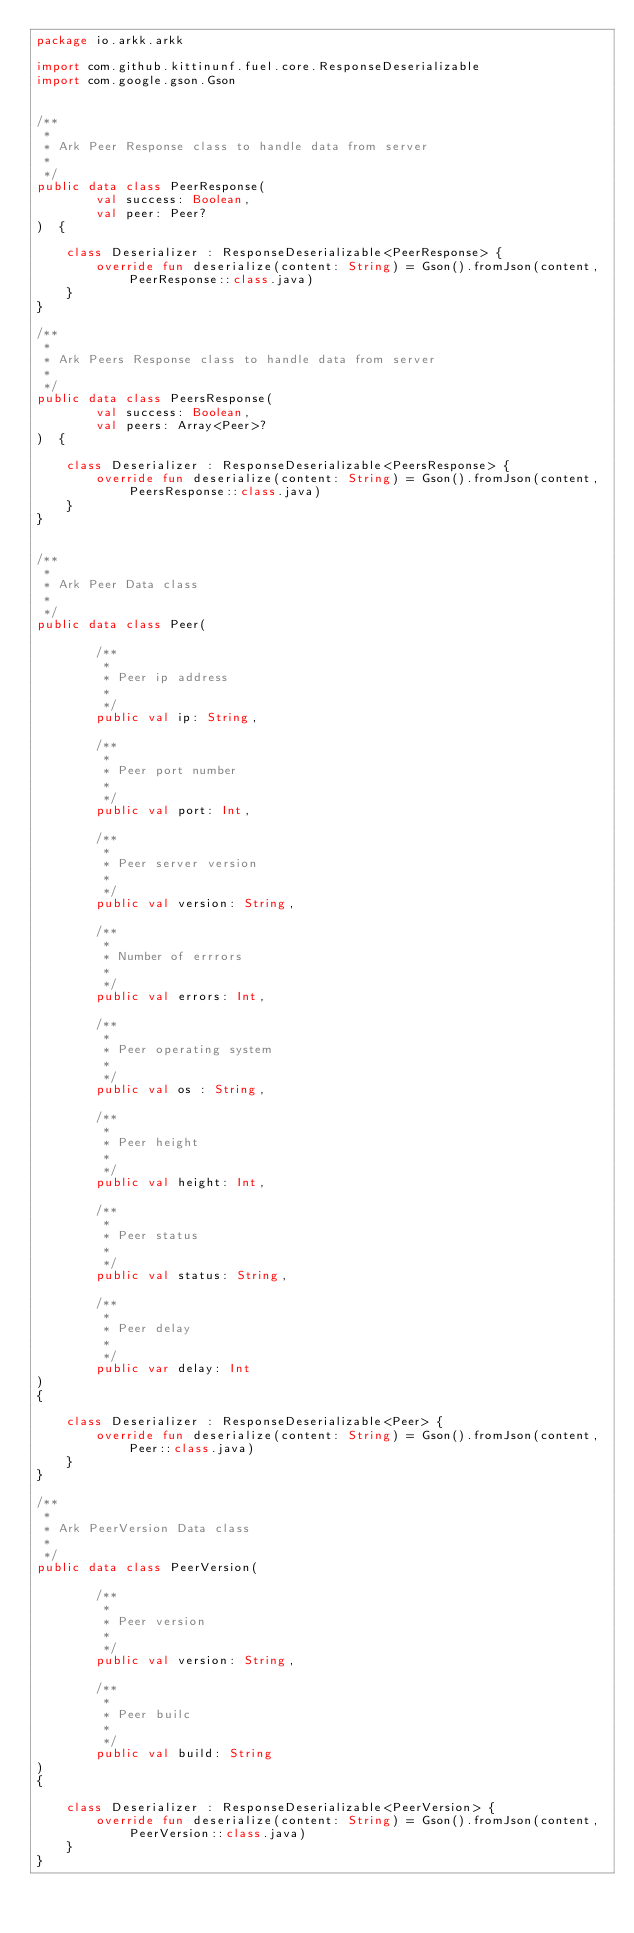<code> <loc_0><loc_0><loc_500><loc_500><_Kotlin_>package io.arkk.arkk

import com.github.kittinunf.fuel.core.ResponseDeserializable
import com.google.gson.Gson


/**
 *
 * Ark Peer Response class to handle data from server
 *
 */
public data class PeerResponse(
        val success: Boolean,
        val peer: Peer?
)  {

    class Deserializer : ResponseDeserializable<PeerResponse> {
        override fun deserialize(content: String) = Gson().fromJson(content, PeerResponse::class.java)
    }
}

/**
 *
 * Ark Peers Response class to handle data from server
 *
 */
public data class PeersResponse(
        val success: Boolean,
        val peers: Array<Peer>?
)  {

    class Deserializer : ResponseDeserializable<PeersResponse> {
        override fun deserialize(content: String) = Gson().fromJson(content, PeersResponse::class.java)
    }
}


/**
 *
 * Ark Peer Data class
 *
 */
public data class Peer(

        /**
         *
         * Peer ip address
         *
         */
        public val ip: String,

        /**
         *
         * Peer port number
         *
         */
        public val port: Int,

        /**
         *
         * Peer server version
         *
         */
        public val version: String,

        /**
         *
         * Number of errrors
         *
         */
        public val errors: Int,

        /**
         *
         * Peer operating system
         *
         */
        public val os : String,

        /**
         *
         * Peer height
         *
         */
        public val height: Int,

        /**
         *
         * Peer status
         *
         */
        public val status: String,

        /**
         *
         * Peer delay
         *
         */
        public var delay: Int
)
{

    class Deserializer : ResponseDeserializable<Peer> {
        override fun deserialize(content: String) = Gson().fromJson(content, Peer::class.java)
    }
}

/**
 *
 * Ark PeerVersion Data class
 *
 */
public data class PeerVersion(

        /**
         *
         * Peer version
         *
         */
        public val version: String,

        /**
         *
         * Peer builc
         *
         */
        public val build: String
)
{

    class Deserializer : ResponseDeserializable<PeerVersion> {
        override fun deserialize(content: String) = Gson().fromJson(content, PeerVersion::class.java)
    }
}



</code> 